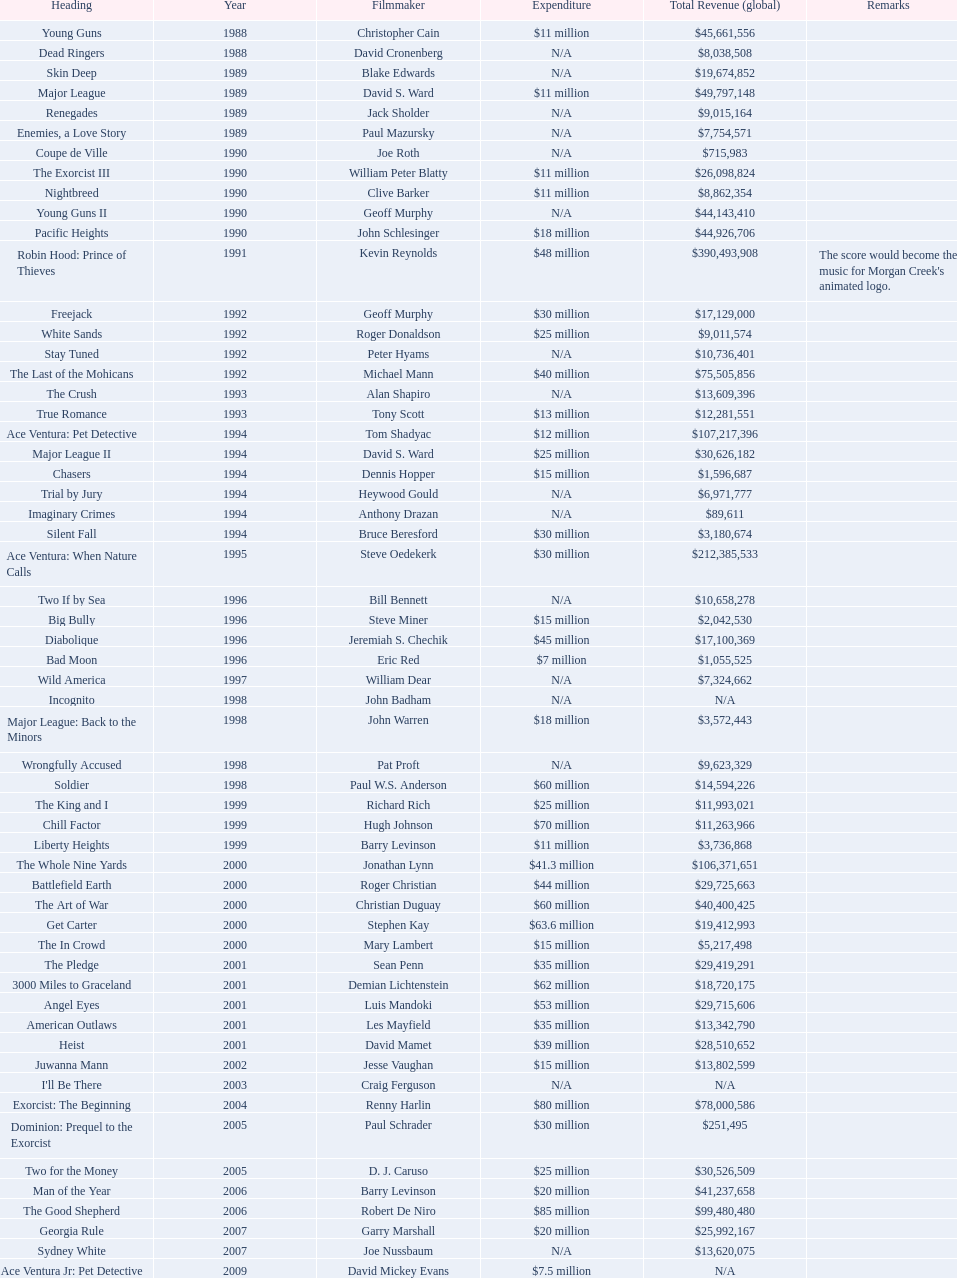What was the only movie with a 48 million dollar budget? Robin Hood: Prince of Thieves. 